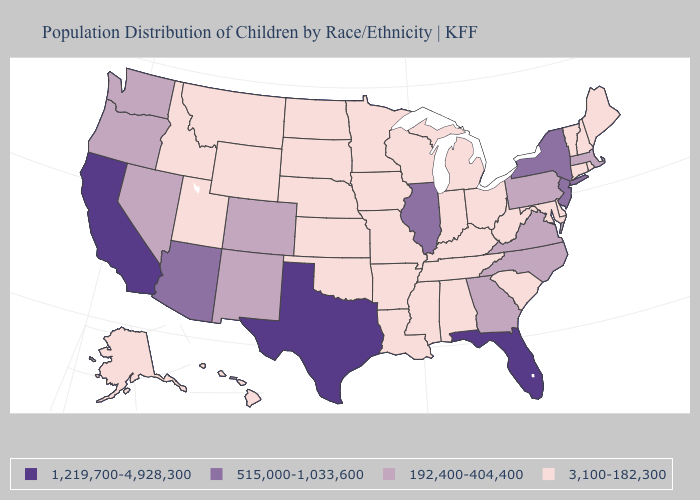Does New Jersey have the same value as Wisconsin?
Be succinct. No. Name the states that have a value in the range 192,400-404,400?
Concise answer only. Colorado, Georgia, Massachusetts, Nevada, New Mexico, North Carolina, Oregon, Pennsylvania, Virginia, Washington. Name the states that have a value in the range 1,219,700-4,928,300?
Concise answer only. California, Florida, Texas. What is the value of Arizona?
Concise answer only. 515,000-1,033,600. Name the states that have a value in the range 3,100-182,300?
Concise answer only. Alabama, Alaska, Arkansas, Connecticut, Delaware, Hawaii, Idaho, Indiana, Iowa, Kansas, Kentucky, Louisiana, Maine, Maryland, Michigan, Minnesota, Mississippi, Missouri, Montana, Nebraska, New Hampshire, North Dakota, Ohio, Oklahoma, Rhode Island, South Carolina, South Dakota, Tennessee, Utah, Vermont, West Virginia, Wisconsin, Wyoming. Which states have the highest value in the USA?
Short answer required. California, Florida, Texas. Name the states that have a value in the range 515,000-1,033,600?
Give a very brief answer. Arizona, Illinois, New Jersey, New York. What is the value of South Dakota?
Short answer required. 3,100-182,300. What is the lowest value in the MidWest?
Keep it brief. 3,100-182,300. What is the value of Alaska?
Give a very brief answer. 3,100-182,300. How many symbols are there in the legend?
Concise answer only. 4. What is the highest value in the Northeast ?
Answer briefly. 515,000-1,033,600. Name the states that have a value in the range 515,000-1,033,600?
Answer briefly. Arizona, Illinois, New Jersey, New York. Name the states that have a value in the range 1,219,700-4,928,300?
Concise answer only. California, Florida, Texas. What is the value of Louisiana?
Short answer required. 3,100-182,300. 